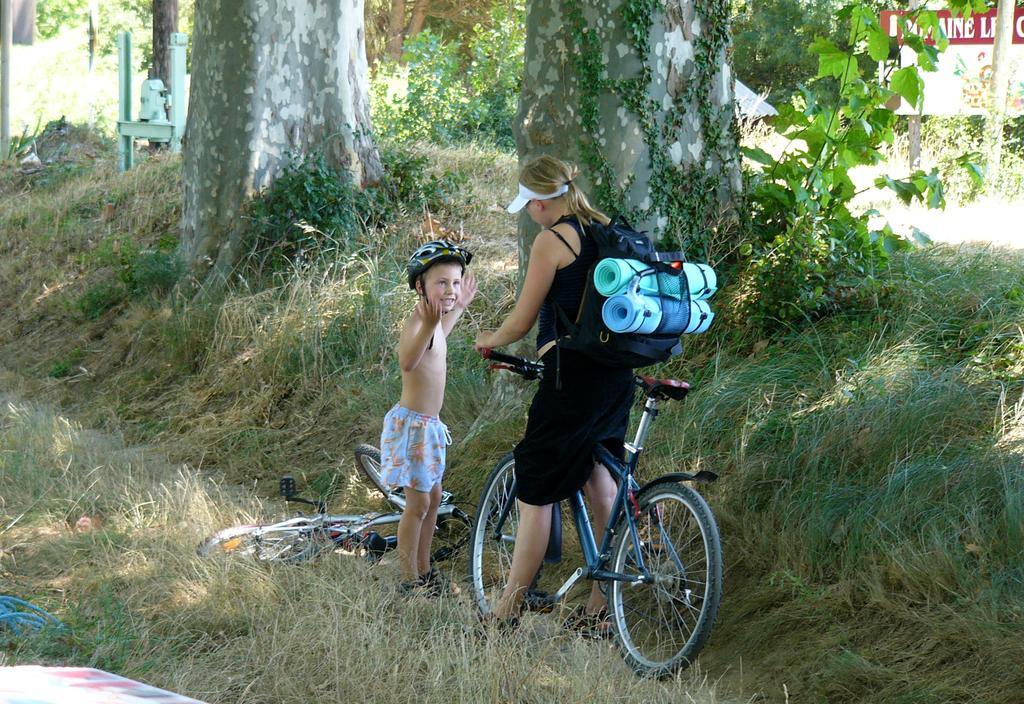What is the woman doing in the image? The woman is on a bicycle in the image. What safety precaution is the boy taking in the image? The boy is wearing a helmet in the image. What is the condition of the second bicycle in the image? There is another bicycle on the ground in the image. What type of natural environment is visible in the background of the image? Trees and grass are visible in the background of the image. What type of grain is being harvested by the steam-powered machine in the image? There is no steam-powered machine or grain present in the image; it features a woman on a bicycle, a boy wearing a helmet, and another bicycle on the ground. Is the woman on the bicycle sleeping in the image? No, the woman is not sleeping in the image; she is riding a bicycle. 